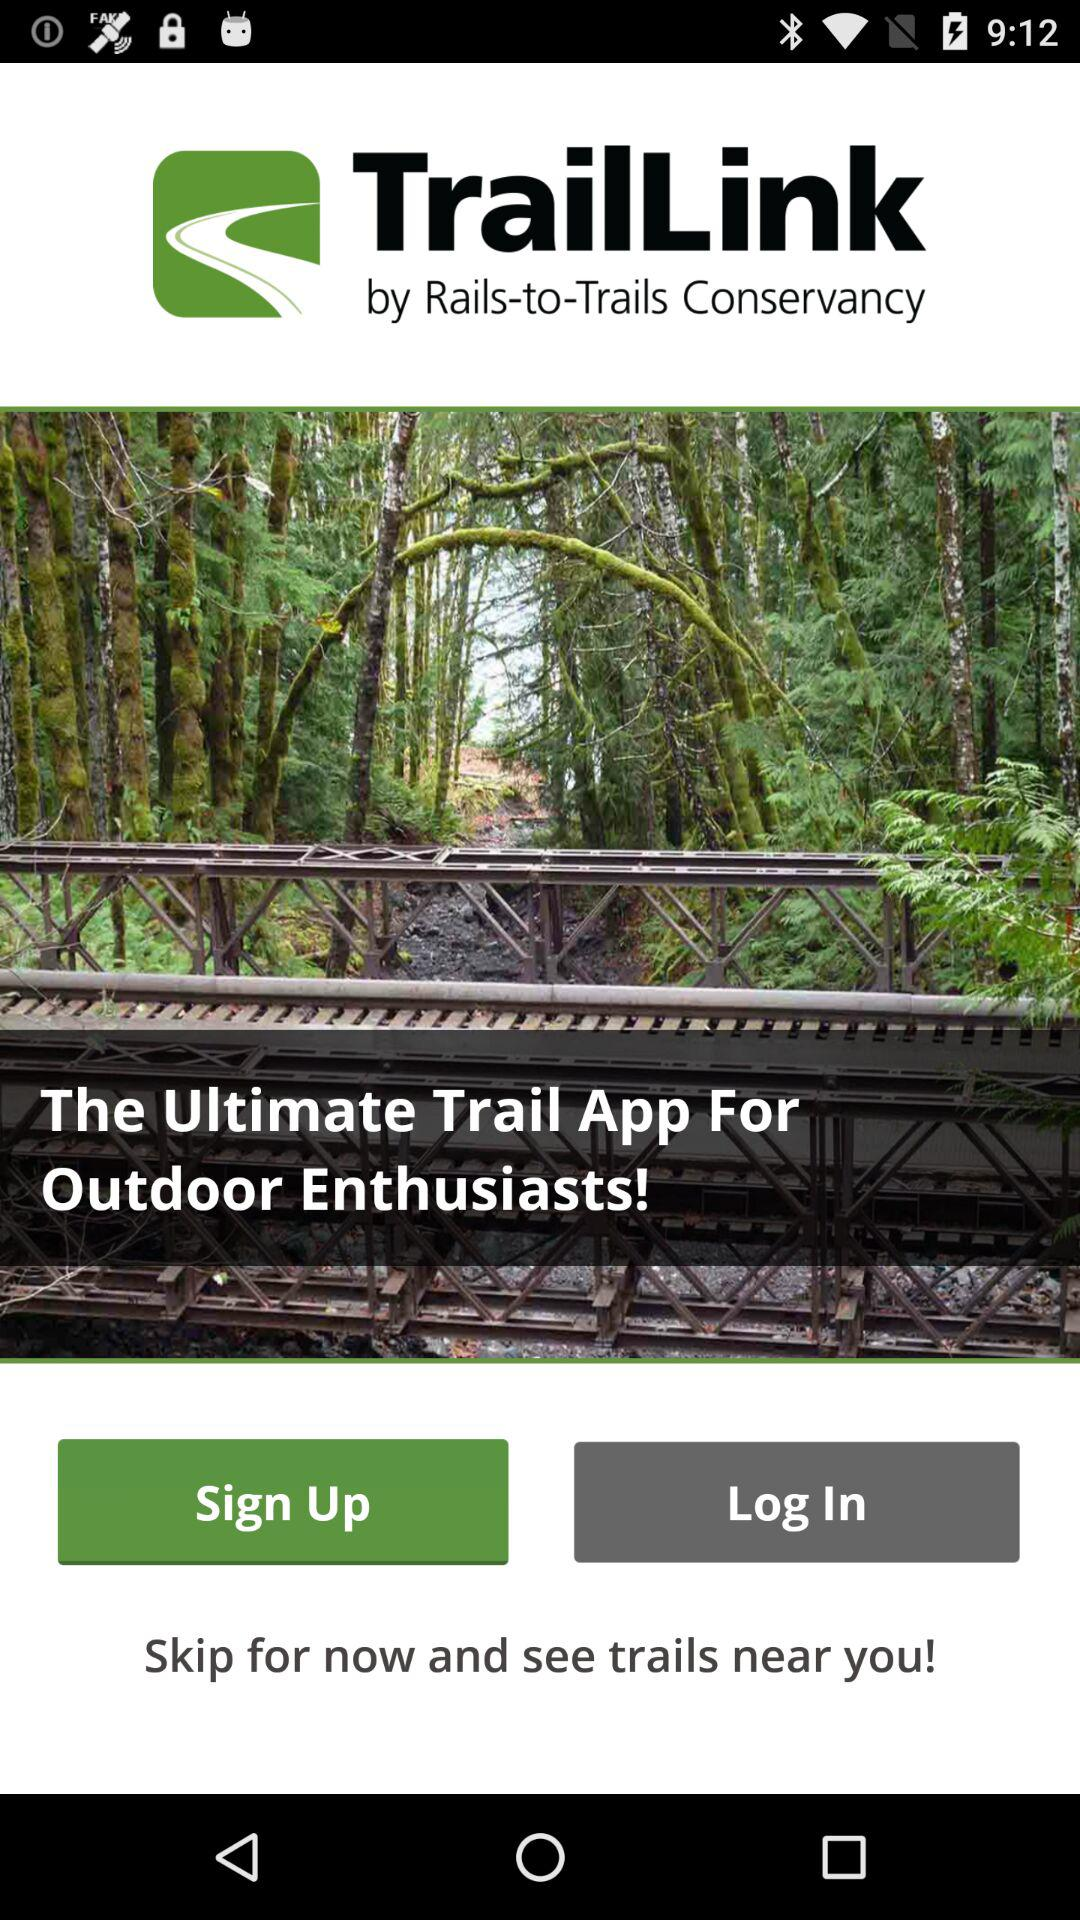What is the app name? The app name is "TrailLink". 